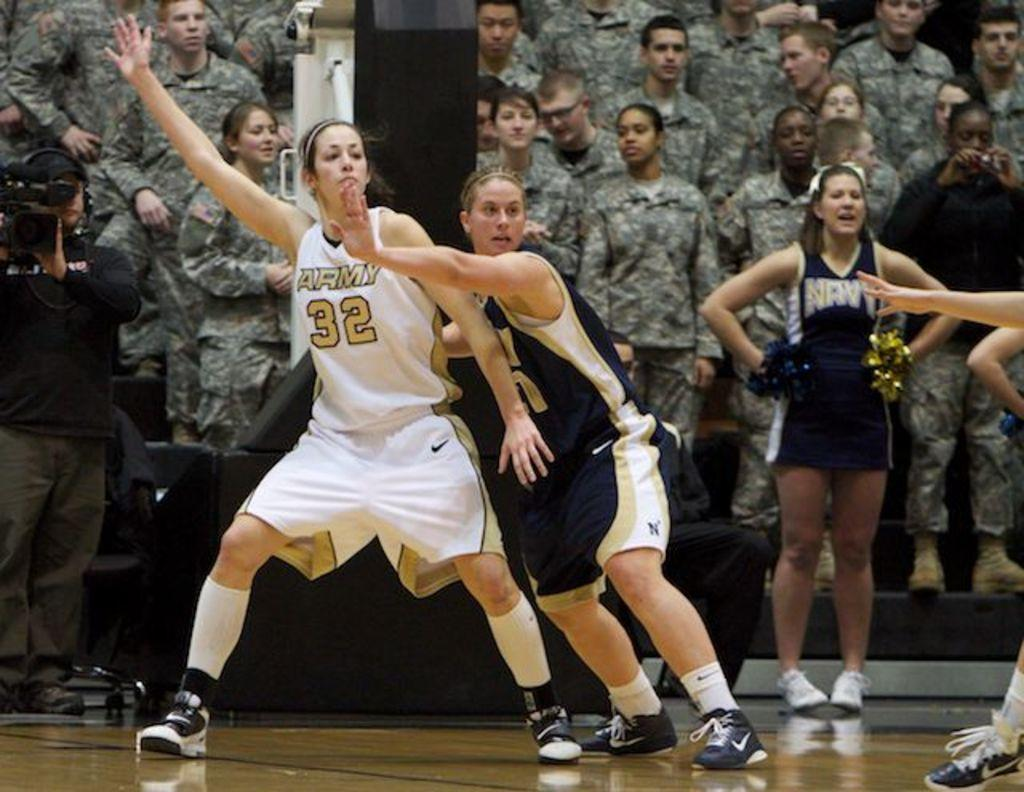<image>
Describe the image concisely. A girl playing basketball has a 32 on her jersey. 